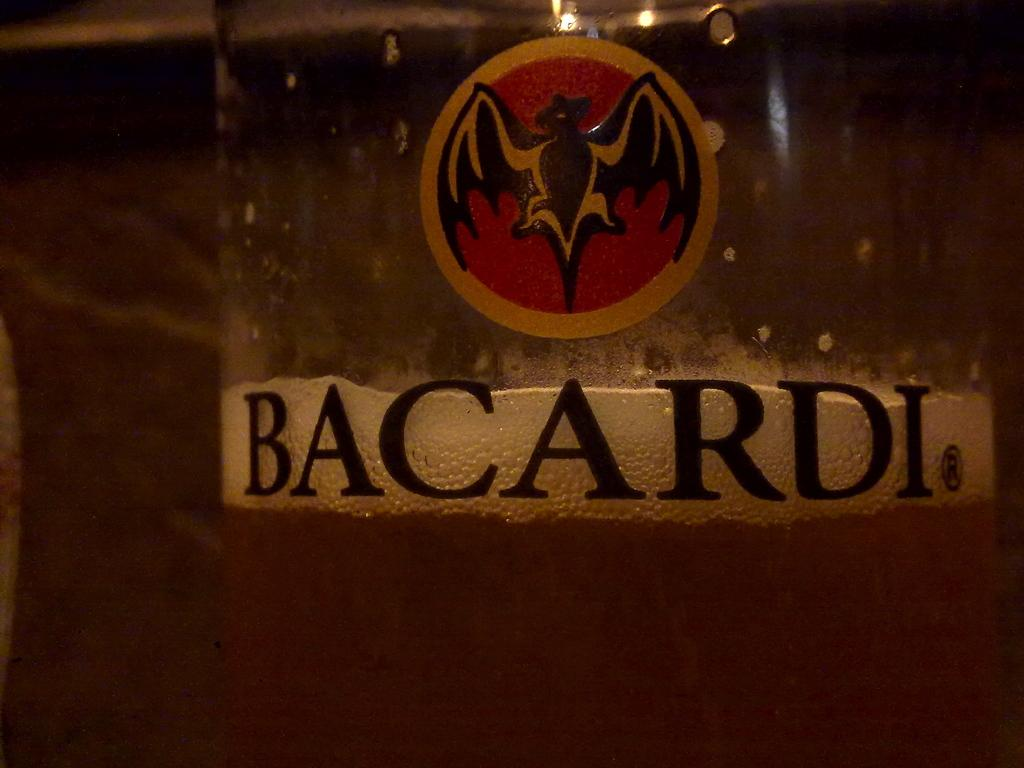What can be seen in the image that has a design or image on it? There is a sticker in the image. What is written or printed on the glass in the image? There is text on a glass in the image. What is contained in the glass? There is a drink in the glass. How would you describe the background of the image? The background of the image is blurry. How many flowers are on the sticker in the image? There are no flowers present on the sticker in the image. Can you describe the kittens playing with the cable in the image? There are no kittens or cables present in the image. 